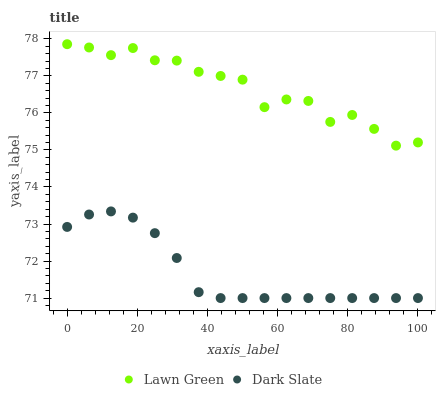Does Dark Slate have the minimum area under the curve?
Answer yes or no. Yes. Does Lawn Green have the maximum area under the curve?
Answer yes or no. Yes. Does Dark Slate have the maximum area under the curve?
Answer yes or no. No. Is Dark Slate the smoothest?
Answer yes or no. Yes. Is Lawn Green the roughest?
Answer yes or no. Yes. Is Dark Slate the roughest?
Answer yes or no. No. Does Dark Slate have the lowest value?
Answer yes or no. Yes. Does Lawn Green have the highest value?
Answer yes or no. Yes. Does Dark Slate have the highest value?
Answer yes or no. No. Is Dark Slate less than Lawn Green?
Answer yes or no. Yes. Is Lawn Green greater than Dark Slate?
Answer yes or no. Yes. Does Dark Slate intersect Lawn Green?
Answer yes or no. No. 